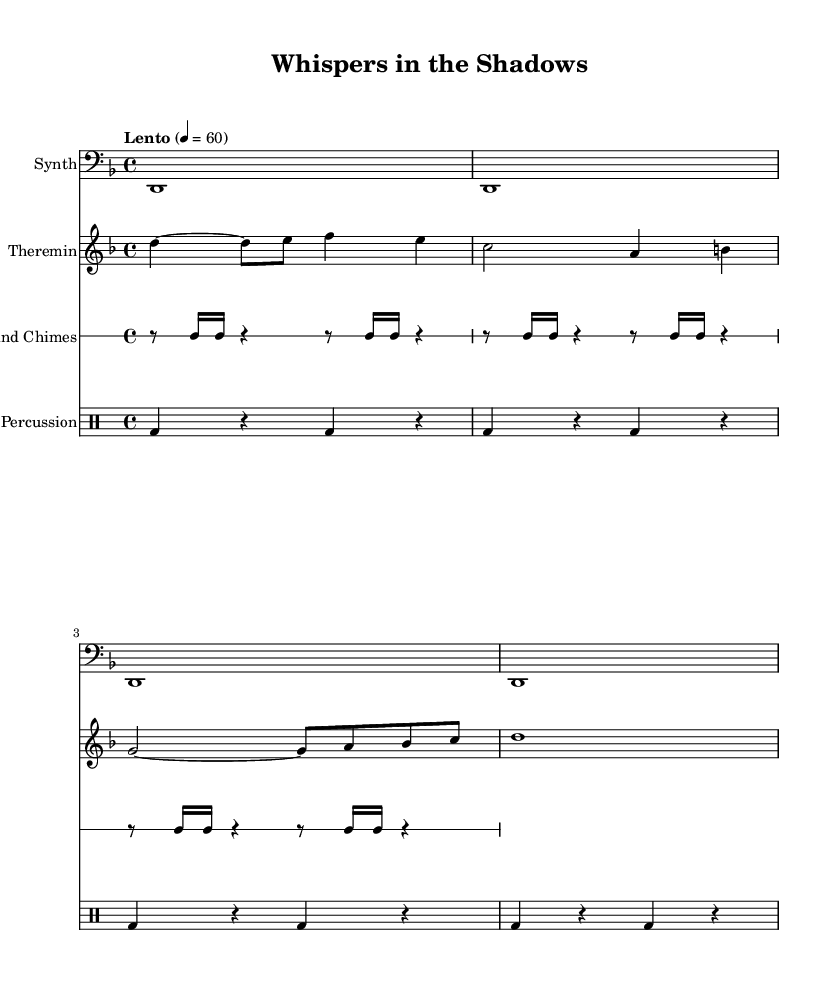What is the key signature of this music? The key signature is D minor, which contains one flat (B flat) and is indicated at the beginning of the staff with its key signature.
Answer: D minor What is the time signature of the piece? The time signature is 4/4, which is presented at the beginning of the score and means there are four beats in each measure.
Answer: 4/4 What is the tempo marking of the music? The tempo marking is "Lento", indicating a slow tempo. The specific beat is set at 60 beats per minute, shown as a quarter note equals 60.
Answer: Lento How many measures are there in the synth drone part? The synth drone consists of five measures, which can be counted by analyzing the vertical lines separating each measure in the staff.
Answer: 5 What instrument is playing the theremin part? The theremin part is played by a voice on the treble clef, indicated by the specific clef symbol at the beginning of the staff.
Answer: Theremin How many total notes are in the wind chimes part? The wind chimes part contains a total of 12 notes. This is determined by counting each distinct note in the staff where the wind chimes are written.
Answer: 12 What is the drum pattern in the percussion part? The drum pattern consists of alternating bass drum hits every quarter note, linked by rests, as shown in the percussion staff notation.
Answer: Bass drum 